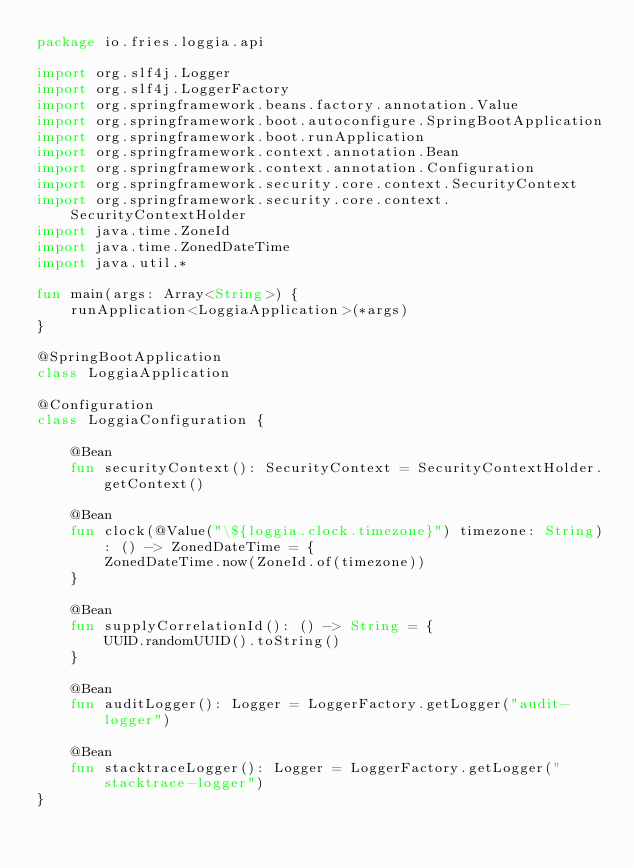<code> <loc_0><loc_0><loc_500><loc_500><_Kotlin_>package io.fries.loggia.api

import org.slf4j.Logger
import org.slf4j.LoggerFactory
import org.springframework.beans.factory.annotation.Value
import org.springframework.boot.autoconfigure.SpringBootApplication
import org.springframework.boot.runApplication
import org.springframework.context.annotation.Bean
import org.springframework.context.annotation.Configuration
import org.springframework.security.core.context.SecurityContext
import org.springframework.security.core.context.SecurityContextHolder
import java.time.ZoneId
import java.time.ZonedDateTime
import java.util.*

fun main(args: Array<String>) {
    runApplication<LoggiaApplication>(*args)
}

@SpringBootApplication
class LoggiaApplication

@Configuration
class LoggiaConfiguration {

    @Bean
    fun securityContext(): SecurityContext = SecurityContextHolder.getContext()

    @Bean
    fun clock(@Value("\${loggia.clock.timezone}") timezone: String): () -> ZonedDateTime = {
        ZonedDateTime.now(ZoneId.of(timezone))
    }

    @Bean
    fun supplyCorrelationId(): () -> String = {
        UUID.randomUUID().toString()
    }

    @Bean
    fun auditLogger(): Logger = LoggerFactory.getLogger("audit-logger")

    @Bean
    fun stacktraceLogger(): Logger = LoggerFactory.getLogger("stacktrace-logger")
}</code> 